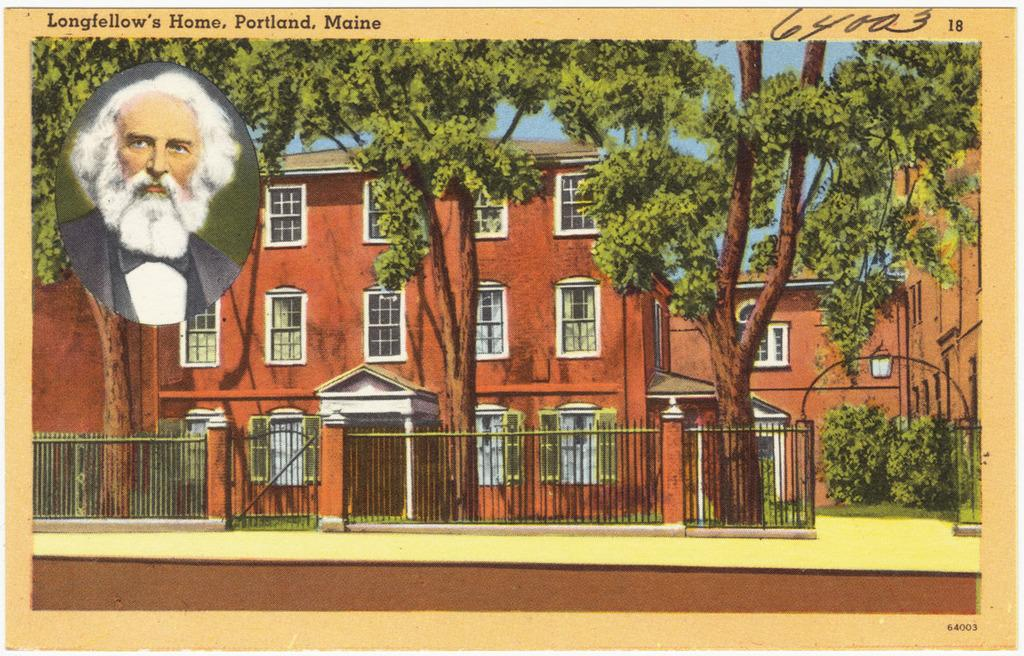What type of visual representation is shown in the image? The image is a poster. What is the main subject of the poster? There is a building depicted in the poster. What is located in front of the building in the poster? There are trees and fencing in front of the building in the poster. Is there any human presence in the poster? Yes, there is an image of a person in the poster. How many visitors are shown in the poster? There is no indication of visitors in the poster; it only depicts a building, trees, fencing, and an image of a person. 